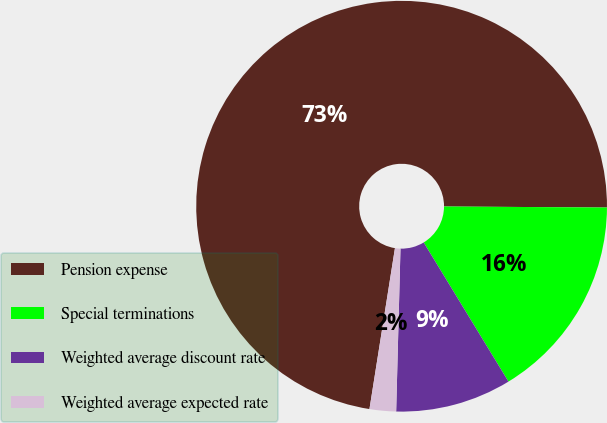Convert chart to OTSL. <chart><loc_0><loc_0><loc_500><loc_500><pie_chart><fcel>Pension expense<fcel>Special terminations<fcel>Weighted average discount rate<fcel>Weighted average expected rate<nl><fcel>72.6%<fcel>16.19%<fcel>9.13%<fcel>2.08%<nl></chart> 